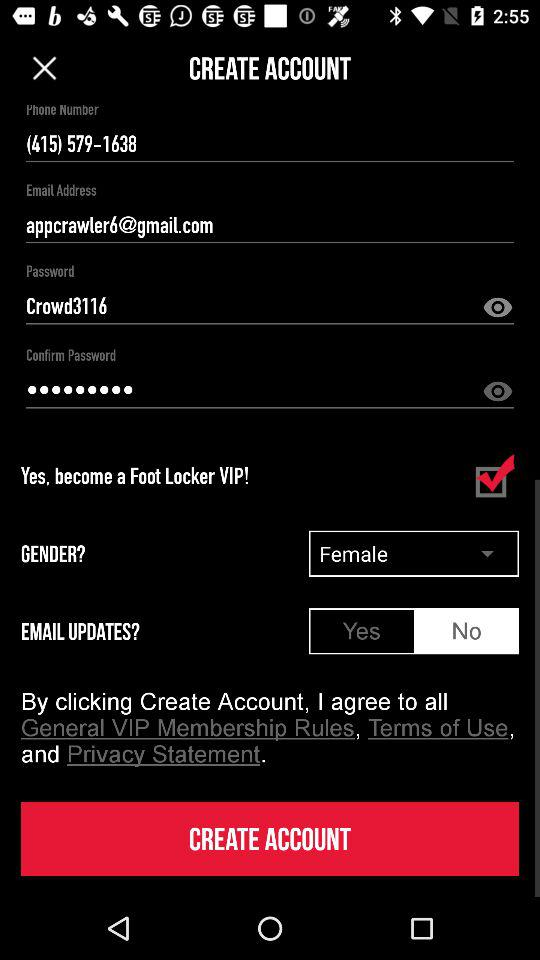Which option is selected in the "GENDER" box? The selected option is "Female". 